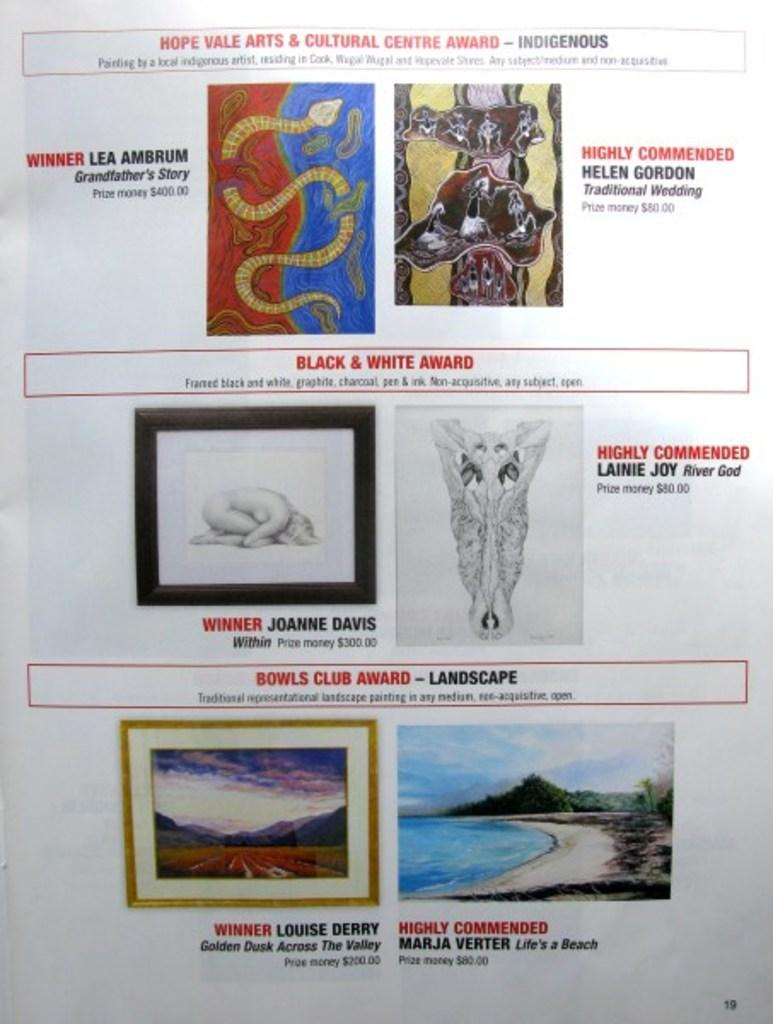What is present in the image that contains both images and text? A: There is a paper in the image that contains images and text. Can you describe the content of the paper in the image? The paper contains images and text. What type of lead can be seen melting on the paper in the image? There is no lead present in the image, and therefore no such activity can be observed. 